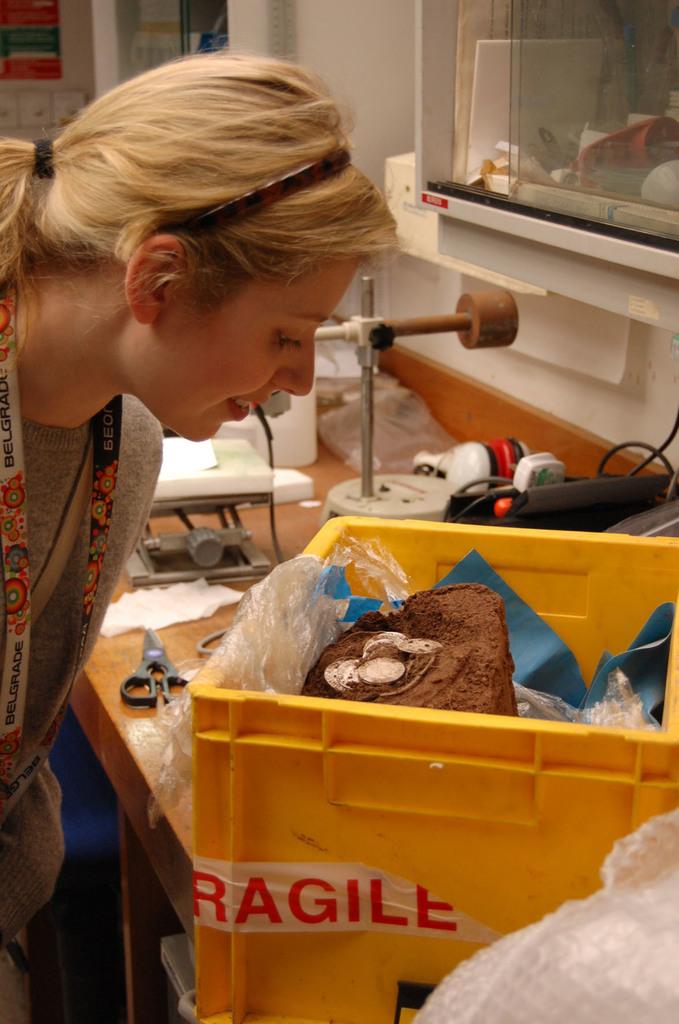Are the contents of the box fragile?
Offer a very short reply. Yes. What city is on the landyard around her neck?
Give a very brief answer. Belgrade. 